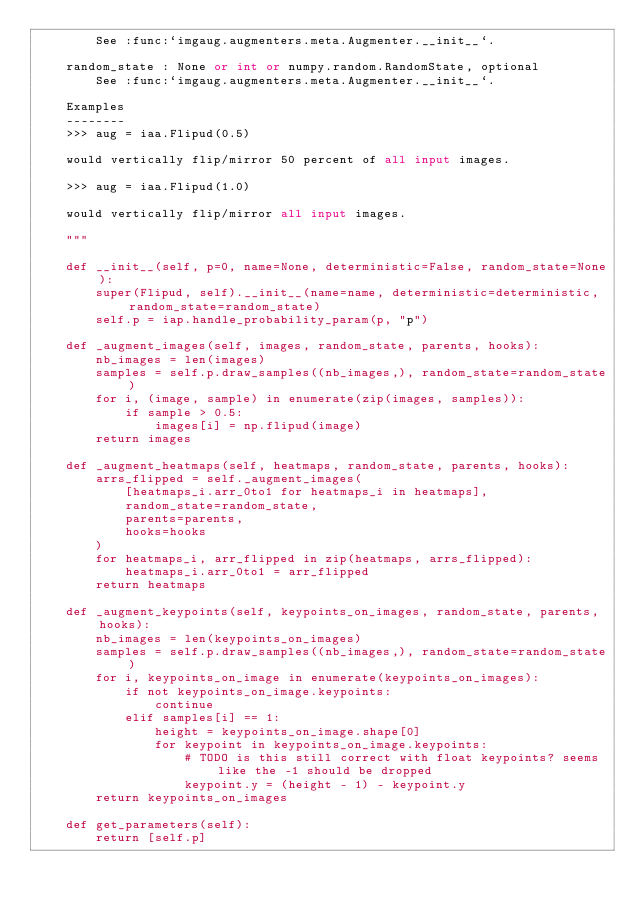<code> <loc_0><loc_0><loc_500><loc_500><_Python_>        See :func:`imgaug.augmenters.meta.Augmenter.__init__`.

    random_state : None or int or numpy.random.RandomState, optional
        See :func:`imgaug.augmenters.meta.Augmenter.__init__`.

    Examples
    --------
    >>> aug = iaa.Flipud(0.5)

    would vertically flip/mirror 50 percent of all input images.

    >>> aug = iaa.Flipud(1.0)

    would vertically flip/mirror all input images.

    """

    def __init__(self, p=0, name=None, deterministic=False, random_state=None):
        super(Flipud, self).__init__(name=name, deterministic=deterministic, random_state=random_state)
        self.p = iap.handle_probability_param(p, "p")

    def _augment_images(self, images, random_state, parents, hooks):
        nb_images = len(images)
        samples = self.p.draw_samples((nb_images,), random_state=random_state)
        for i, (image, sample) in enumerate(zip(images, samples)):
            if sample > 0.5:
                images[i] = np.flipud(image)
        return images

    def _augment_heatmaps(self, heatmaps, random_state, parents, hooks):
        arrs_flipped = self._augment_images(
            [heatmaps_i.arr_0to1 for heatmaps_i in heatmaps],
            random_state=random_state,
            parents=parents,
            hooks=hooks
        )
        for heatmaps_i, arr_flipped in zip(heatmaps, arrs_flipped):
            heatmaps_i.arr_0to1 = arr_flipped
        return heatmaps

    def _augment_keypoints(self, keypoints_on_images, random_state, parents, hooks):
        nb_images = len(keypoints_on_images)
        samples = self.p.draw_samples((nb_images,), random_state=random_state)
        for i, keypoints_on_image in enumerate(keypoints_on_images):
            if not keypoints_on_image.keypoints:
                continue
            elif samples[i] == 1:
                height = keypoints_on_image.shape[0]
                for keypoint in keypoints_on_image.keypoints:
                    # TODO is this still correct with float keypoints? seems like the -1 should be dropped
                    keypoint.y = (height - 1) - keypoint.y
        return keypoints_on_images

    def get_parameters(self):
        return [self.p]
</code> 